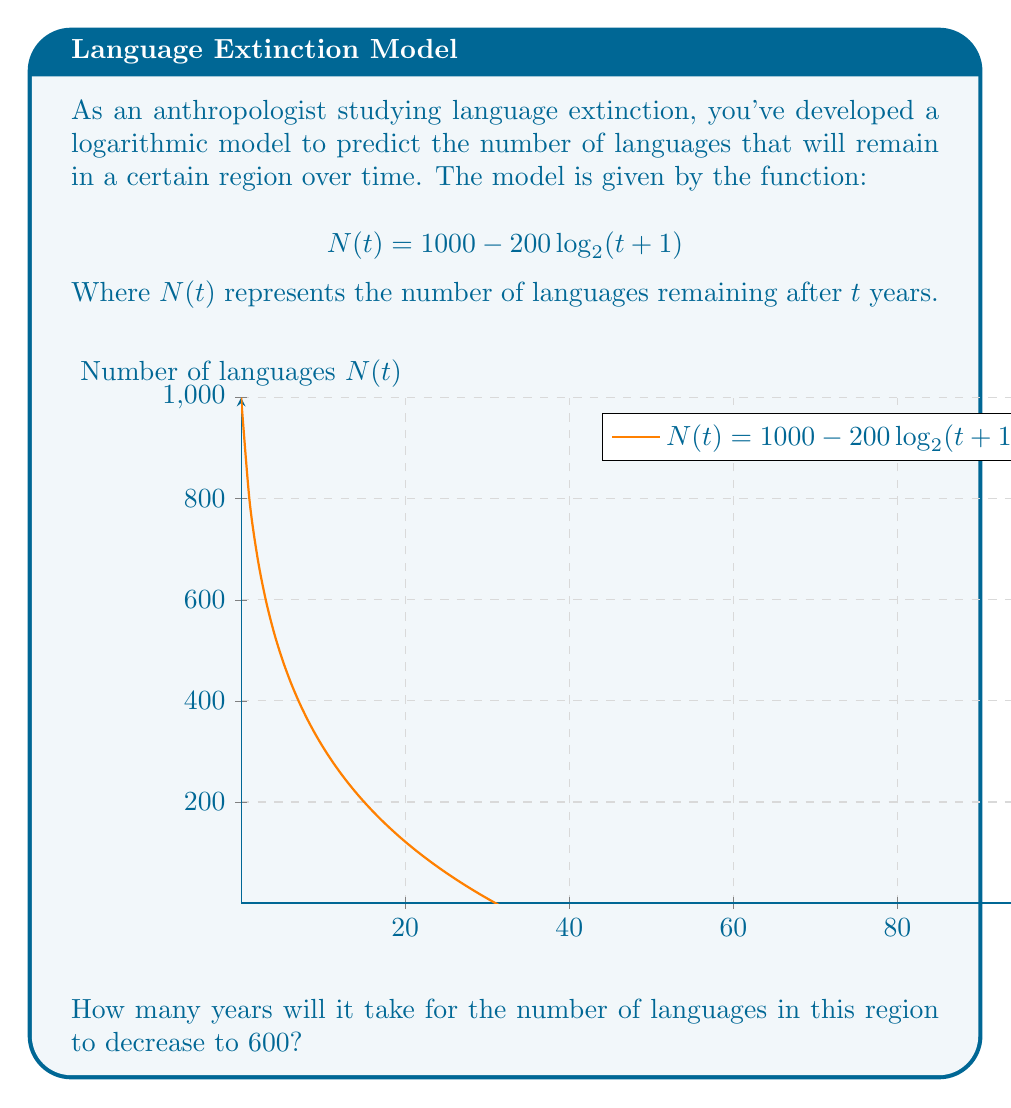Can you answer this question? Let's approach this step-by-step:

1) We want to find $t$ when $N(t) = 600$. So, we can set up the equation:

   $600 = 1000 - 200 \log_{2}(t+1)$

2) Subtract 1000 from both sides:

   $-400 = -200 \log_{2}(t+1)$

3) Divide both sides by -200:

   $2 = \log_{2}(t+1)$

4) Now, we need to solve for $t$. We can do this by applying $2^x$ to both sides:

   $2^2 = 2^{\log_{2}(t+1)}$

5) Simplify the left side:

   $4 = t+1$

6) Subtract 1 from both sides:

   $3 = t$

Therefore, it will take 3 years for the number of languages to decrease to 600.

This logarithmic model reflects the nature of language extinction: rapid initial decline followed by a slower rate of loss, which aligns with anthropological observations of cultural change under pressure.
Answer: 3 years 